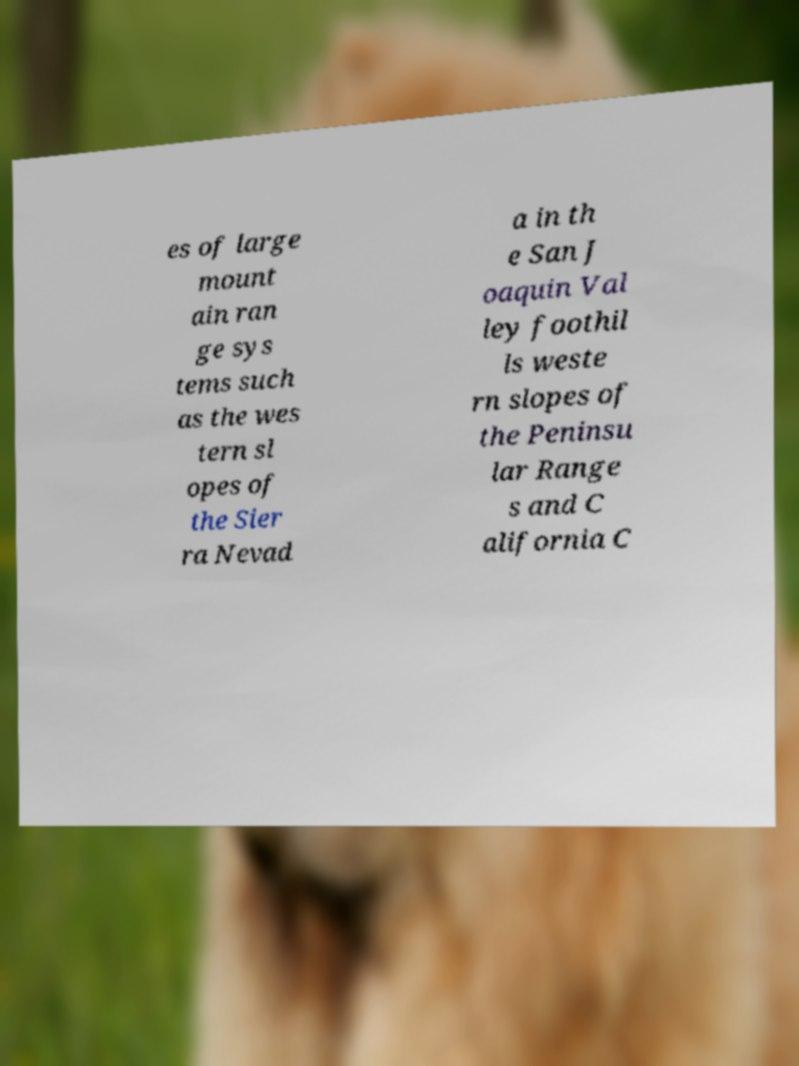For documentation purposes, I need the text within this image transcribed. Could you provide that? es of large mount ain ran ge sys tems such as the wes tern sl opes of the Sier ra Nevad a in th e San J oaquin Val ley foothil ls weste rn slopes of the Peninsu lar Range s and C alifornia C 